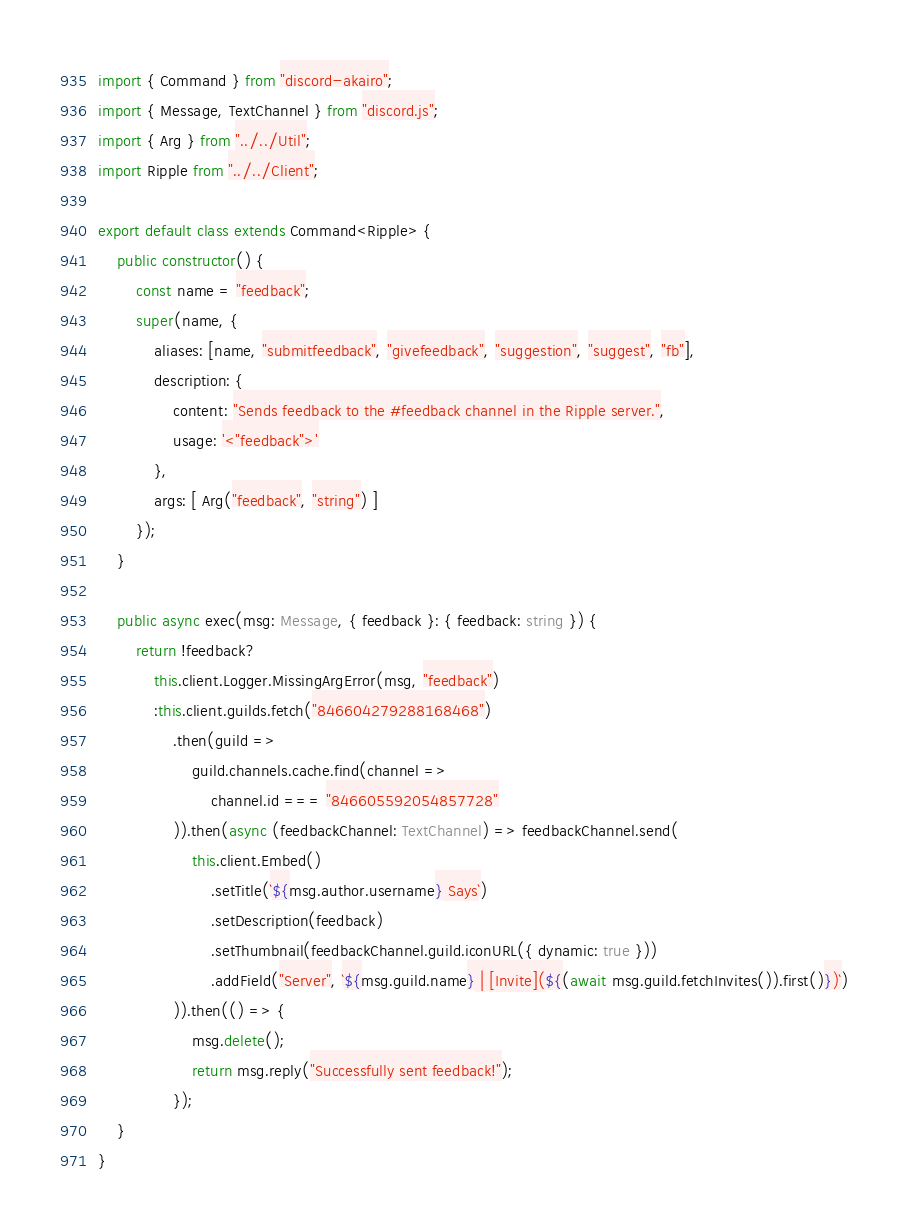<code> <loc_0><loc_0><loc_500><loc_500><_TypeScript_>import { Command } from "discord-akairo";
import { Message, TextChannel } from "discord.js";
import { Arg } from "../../Util";
import Ripple from "../../Client";

export default class extends Command<Ripple> {
    public constructor() {
        const name = "feedback";
        super(name, {
            aliases: [name, "submitfeedback", "givefeedback", "suggestion", "suggest", "fb"],
            description: {
                content: "Sends feedback to the #feedback channel in the Ripple server.",
                usage: '<"feedback">'
            },
            args: [ Arg("feedback", "string") ]
        });
    }

    public async exec(msg: Message, { feedback }: { feedback: string }) {
        return !feedback?
            this.client.Logger.MissingArgError(msg, "feedback")
            :this.client.guilds.fetch("846604279288168468")
                .then(guild => 
                    guild.channels.cache.find(channel => 
                        channel.id === "846605592054857728"
                )).then(async (feedbackChannel: TextChannel) => feedbackChannel.send(
                    this.client.Embed()
                        .setTitle(`${msg.author.username} Says`)
                        .setDescription(feedback)
                        .setThumbnail(feedbackChannel.guild.iconURL({ dynamic: true }))
                        .addField("Server", `${msg.guild.name} | [Invite](${(await msg.guild.fetchInvites()).first()})`)
                )).then(() => {
                    msg.delete();
                    return msg.reply("Successfully sent feedback!");
                });
    }
}</code> 